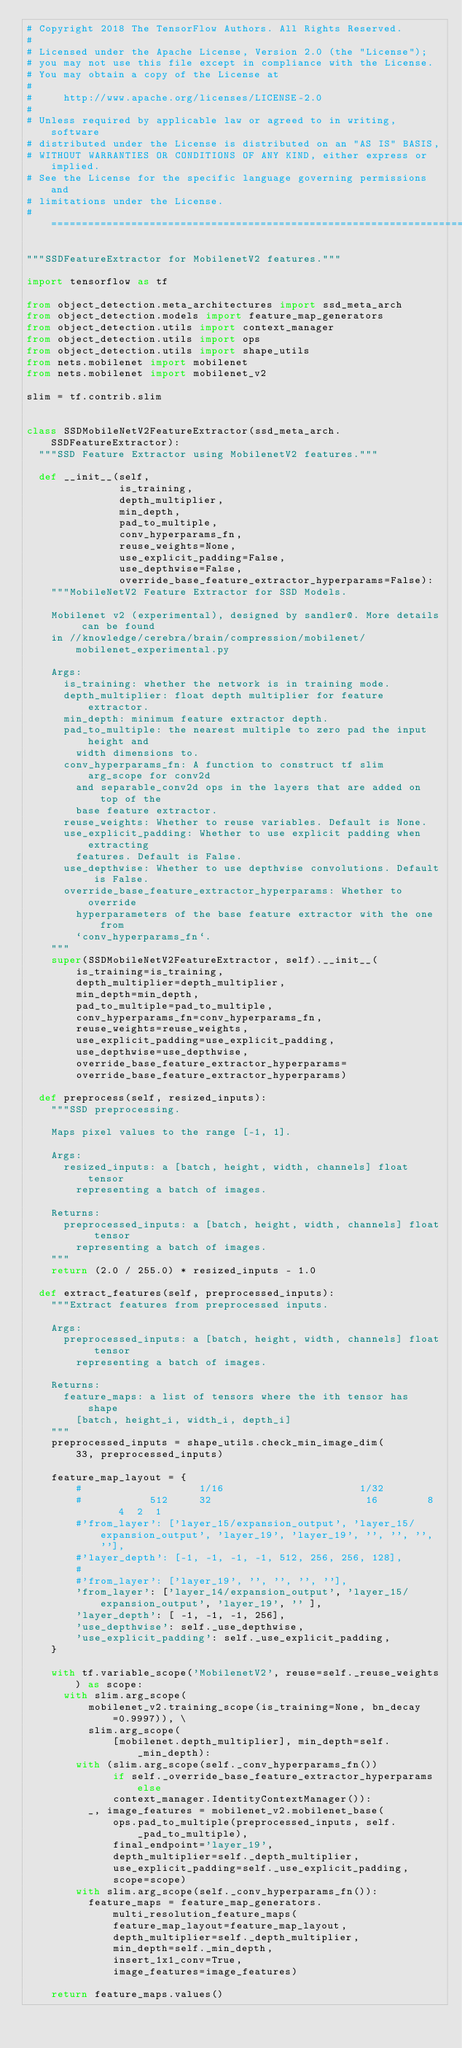<code> <loc_0><loc_0><loc_500><loc_500><_Python_># Copyright 2018 The TensorFlow Authors. All Rights Reserved.
#
# Licensed under the Apache License, Version 2.0 (the "License");
# you may not use this file except in compliance with the License.
# You may obtain a copy of the License at
#
#     http://www.apache.org/licenses/LICENSE-2.0
#
# Unless required by applicable law or agreed to in writing, software
# distributed under the License is distributed on an "AS IS" BASIS,
# WITHOUT WARRANTIES OR CONDITIONS OF ANY KIND, either express or implied.
# See the License for the specific language governing permissions and
# limitations under the License.
# ==============================================================================

"""SSDFeatureExtractor for MobilenetV2 features."""

import tensorflow as tf

from object_detection.meta_architectures import ssd_meta_arch
from object_detection.models import feature_map_generators
from object_detection.utils import context_manager
from object_detection.utils import ops
from object_detection.utils import shape_utils
from nets.mobilenet import mobilenet
from nets.mobilenet import mobilenet_v2

slim = tf.contrib.slim


class SSDMobileNetV2FeatureExtractor(ssd_meta_arch.SSDFeatureExtractor):
  """SSD Feature Extractor using MobilenetV2 features."""

  def __init__(self,
               is_training,
               depth_multiplier,
               min_depth,
               pad_to_multiple,
               conv_hyperparams_fn,
               reuse_weights=None,
               use_explicit_padding=False,
               use_depthwise=False,
               override_base_feature_extractor_hyperparams=False):
    """MobileNetV2 Feature Extractor for SSD Models.

    Mobilenet v2 (experimental), designed by sandler@. More details can be found
    in //knowledge/cerebra/brain/compression/mobilenet/mobilenet_experimental.py

    Args:
      is_training: whether the network is in training mode.
      depth_multiplier: float depth multiplier for feature extractor.
      min_depth: minimum feature extractor depth.
      pad_to_multiple: the nearest multiple to zero pad the input height and
        width dimensions to.
      conv_hyperparams_fn: A function to construct tf slim arg_scope for conv2d
        and separable_conv2d ops in the layers that are added on top of the
        base feature extractor.
      reuse_weights: Whether to reuse variables. Default is None.
      use_explicit_padding: Whether to use explicit padding when extracting
        features. Default is False.
      use_depthwise: Whether to use depthwise convolutions. Default is False.
      override_base_feature_extractor_hyperparams: Whether to override
        hyperparameters of the base feature extractor with the one from
        `conv_hyperparams_fn`.
    """
    super(SSDMobileNetV2FeatureExtractor, self).__init__(
        is_training=is_training,
        depth_multiplier=depth_multiplier,
        min_depth=min_depth,
        pad_to_multiple=pad_to_multiple,
        conv_hyperparams_fn=conv_hyperparams_fn,
        reuse_weights=reuse_weights,
        use_explicit_padding=use_explicit_padding,
        use_depthwise=use_depthwise,
        override_base_feature_extractor_hyperparams=
        override_base_feature_extractor_hyperparams)

  def preprocess(self, resized_inputs):
    """SSD preprocessing.

    Maps pixel values to the range [-1, 1].

    Args:
      resized_inputs: a [batch, height, width, channels] float tensor
        representing a batch of images.

    Returns:
      preprocessed_inputs: a [batch, height, width, channels] float tensor
        representing a batch of images.
    """
    return (2.0 / 255.0) * resized_inputs - 1.0

  def extract_features(self, preprocessed_inputs):
    """Extract features from preprocessed inputs.

    Args:
      preprocessed_inputs: a [batch, height, width, channels] float tensor
        representing a batch of images.

    Returns:
      feature_maps: a list of tensors where the ith tensor has shape
        [batch, height_i, width_i, depth_i]
    """
    preprocessed_inputs = shape_utils.check_min_image_dim(
        33, preprocessed_inputs)

    feature_map_layout = {
        #                   1/16                      1/32
        #           512     32                         16        8    4  2  1
        #'from_layer': ['layer_15/expansion_output', 'layer_15/expansion_output', 'layer_19', 'layer_19', '', '', '', ''],
        #'layer_depth': [-1, -1, -1, -1, 512, 256, 256, 128],
        #
        #'from_layer': ['layer_19', '', '', '', ''],
        'from_layer': ['layer_14/expansion_output', 'layer_15/expansion_output', 'layer_19', '' ],
        'layer_depth': [ -1, -1, -1, 256],
        'use_depthwise': self._use_depthwise,
        'use_explicit_padding': self._use_explicit_padding,
    }

    with tf.variable_scope('MobilenetV2', reuse=self._reuse_weights) as scope:
      with slim.arg_scope(
          mobilenet_v2.training_scope(is_training=None, bn_decay=0.9997)), \
          slim.arg_scope(
              [mobilenet.depth_multiplier], min_depth=self._min_depth):
        with (slim.arg_scope(self._conv_hyperparams_fn())
              if self._override_base_feature_extractor_hyperparams else
              context_manager.IdentityContextManager()):
          _, image_features = mobilenet_v2.mobilenet_base(
              ops.pad_to_multiple(preprocessed_inputs, self._pad_to_multiple),
              final_endpoint='layer_19',
              depth_multiplier=self._depth_multiplier,
              use_explicit_padding=self._use_explicit_padding,
              scope=scope)
        with slim.arg_scope(self._conv_hyperparams_fn()):
          feature_maps = feature_map_generators.multi_resolution_feature_maps(
              feature_map_layout=feature_map_layout,
              depth_multiplier=self._depth_multiplier,
              min_depth=self._min_depth,
              insert_1x1_conv=True,
              image_features=image_features)

    return feature_maps.values()
</code> 